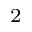Convert formula to latex. <formula><loc_0><loc_0><loc_500><loc_500>^ { 2 }</formula> 